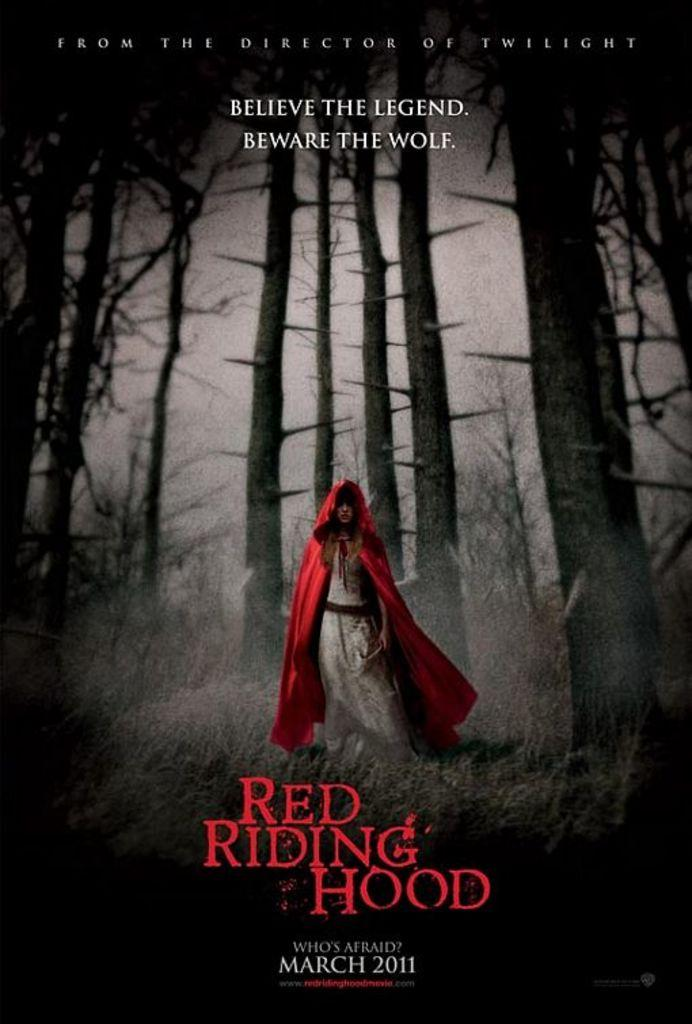<image>
Summarize the visual content of the image. Red Riding Hood DVD from the director of Twilight. 